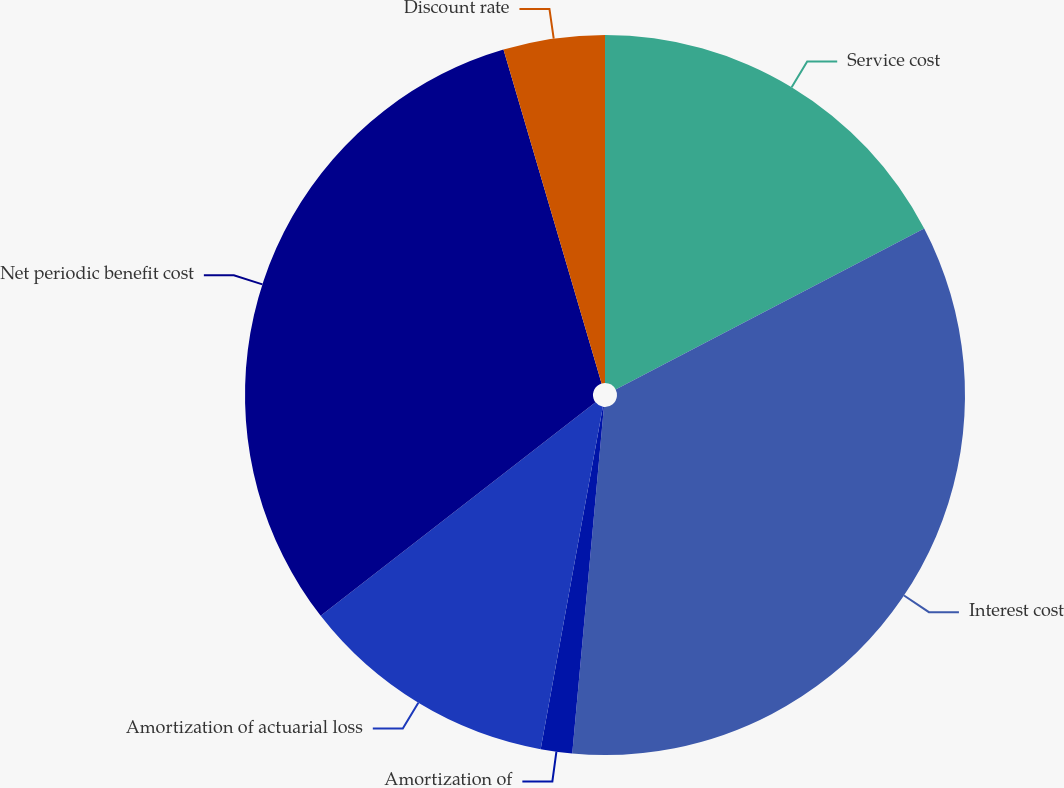Convert chart. <chart><loc_0><loc_0><loc_500><loc_500><pie_chart><fcel>Service cost<fcel>Interest cost<fcel>Amortization of<fcel>Amortization of actuarial loss<fcel>Net periodic benefit cost<fcel>Discount rate<nl><fcel>17.35%<fcel>34.1%<fcel>1.41%<fcel>11.63%<fcel>30.96%<fcel>4.55%<nl></chart> 